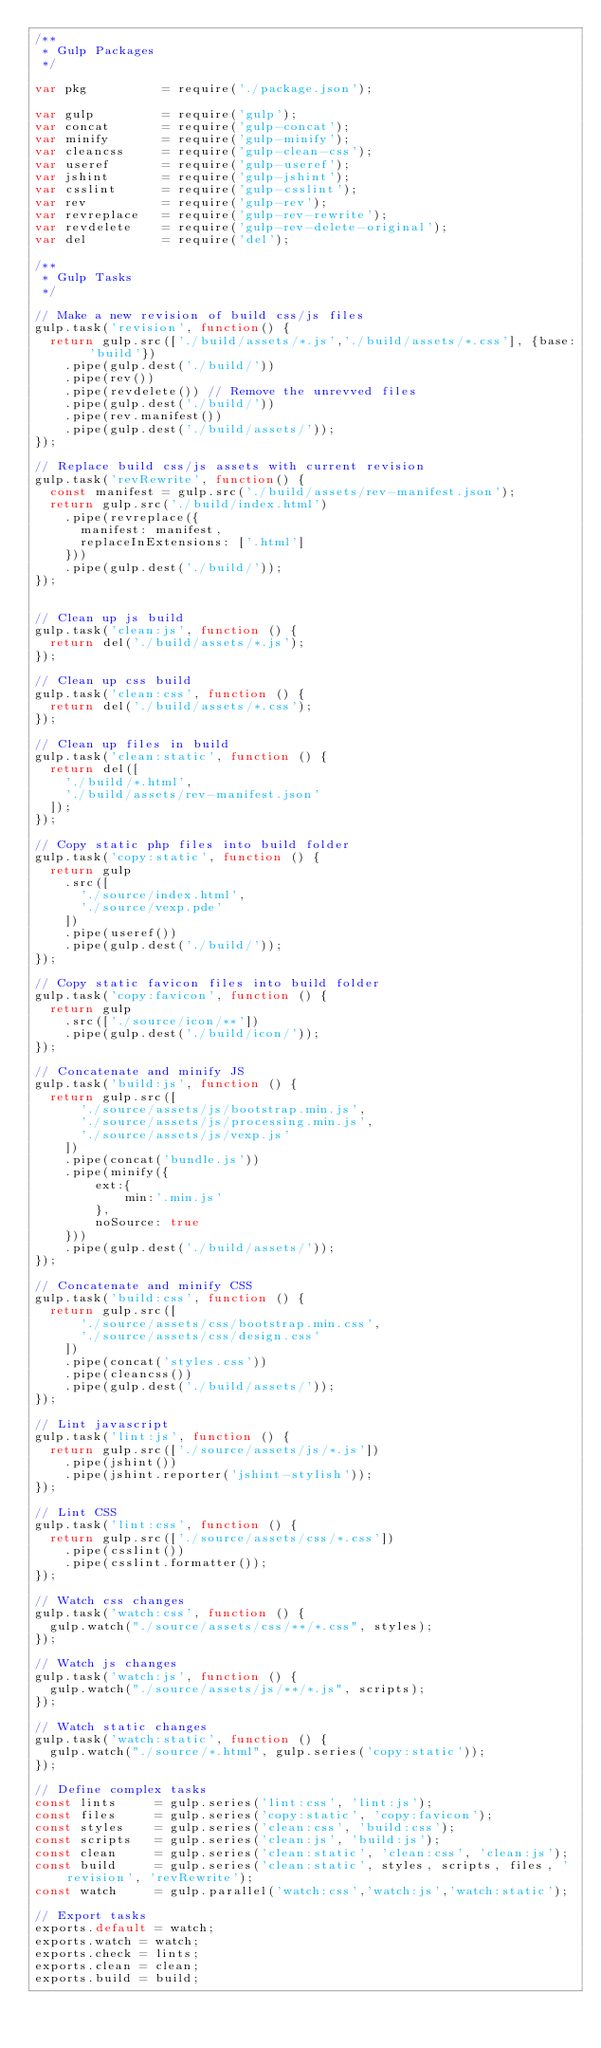<code> <loc_0><loc_0><loc_500><loc_500><_JavaScript_>/**
 * Gulp Packages
 */

var pkg          = require('./package.json');

var gulp         = require('gulp');
var concat       = require('gulp-concat');
var minify       = require('gulp-minify');
var cleancss     = require('gulp-clean-css');
var useref       = require('gulp-useref');
var jshint       = require('gulp-jshint');
var csslint      = require('gulp-csslint');
var rev          = require('gulp-rev');
var revreplace   = require('gulp-rev-rewrite');
var revdelete    = require('gulp-rev-delete-original');
var del          = require('del');

/**
 * Gulp Tasks
 */

// Make a new revision of build css/js files
gulp.task('revision', function() {
  return gulp.src(['./build/assets/*.js','./build/assets/*.css'], {base: 'build'})
    .pipe(gulp.dest('./build/'))
    .pipe(rev())
    .pipe(revdelete()) // Remove the unrevved files
    .pipe(gulp.dest('./build/'))
    .pipe(rev.manifest())
    .pipe(gulp.dest('./build/assets/'));
});

// Replace build css/js assets with current revision
gulp.task('revRewrite', function() {
  const manifest = gulp.src('./build/assets/rev-manifest.json');
  return gulp.src('./build/index.html')
    .pipe(revreplace({
      manifest: manifest,
      replaceInExtensions: ['.html']
    }))
    .pipe(gulp.dest('./build/'));
});


// Clean up js build
gulp.task('clean:js', function () {
  return del('./build/assets/*.js');
});

// Clean up css build
gulp.task('clean:css', function () {
  return del('./build/assets/*.css');
});

// Clean up files in build
gulp.task('clean:static', function () {
  return del([
    './build/*.html',
    './build/assets/rev-manifest.json'
  ]);
});

// Copy static php files into build folder
gulp.task('copy:static', function () {
  return gulp
    .src([
      './source/index.html',
      './source/vexp.pde'
    ])
    .pipe(useref())
    .pipe(gulp.dest('./build/'));
});

// Copy static favicon files into build folder
gulp.task('copy:favicon', function () {
  return gulp
    .src(['./source/icon/**'])
    .pipe(gulp.dest('./build/icon/'));
});

// Concatenate and minify JS
gulp.task('build:js', function () {    
  return gulp.src([
      './source/assets/js/bootstrap.min.js',
      './source/assets/js/processing.min.js',
      './source/assets/js/vexp.js'
    ])
    .pipe(concat('bundle.js'))
    .pipe(minify({
        ext:{
            min:'.min.js'
        },
        noSource: true
    }))
    .pipe(gulp.dest('./build/assets/'));
});

// Concatenate and minify CSS
gulp.task('build:css', function () {    
  return gulp.src([
      './source/assets/css/bootstrap.min.css',
      './source/assets/css/design.css'
    ])
    .pipe(concat('styles.css'))
    .pipe(cleancss())
    .pipe(gulp.dest('./build/assets/'));
});

// Lint javascript
gulp.task('lint:js', function () {    
  return gulp.src(['./source/assets/js/*.js'])
    .pipe(jshint())
    .pipe(jshint.reporter('jshint-stylish'));
});

// Lint CSS
gulp.task('lint:css', function () {    
  return gulp.src(['./source/assets/css/*.css'])
    .pipe(csslint())
    .pipe(csslint.formatter());
});

// Watch css changes
gulp.task('watch:css', function () {
  gulp.watch("./source/assets/css/**/*.css", styles);
});

// Watch js changes
gulp.task('watch:js', function () {
  gulp.watch("./source/assets/js/**/*.js", scripts);
});

// Watch static changes
gulp.task('watch:static', function () {
  gulp.watch("./source/*.html", gulp.series('copy:static'));
});

// Define complex tasks
const lints     = gulp.series('lint:css', 'lint:js');
const files     = gulp.series('copy:static', 'copy:favicon');
const styles    = gulp.series('clean:css', 'build:css');
const scripts   = gulp.series('clean:js', 'build:js');
const clean     = gulp.series('clean:static', 'clean:css', 'clean:js');
const build     = gulp.series('clean:static', styles, scripts, files, 'revision', 'revRewrite');
const watch     = gulp.parallel('watch:css','watch:js','watch:static');

// Export tasks
exports.default = watch;
exports.watch = watch;
exports.check = lints;
exports.clean = clean;
exports.build = build;
</code> 